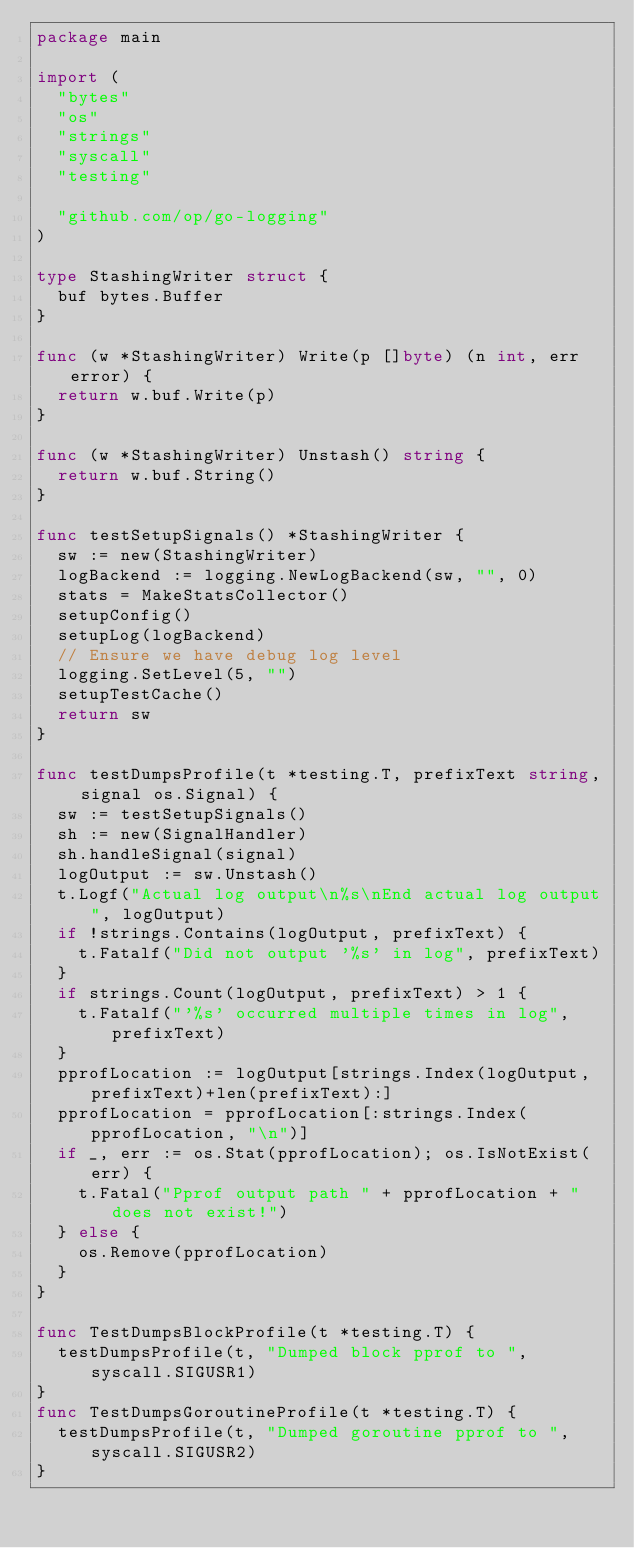Convert code to text. <code><loc_0><loc_0><loc_500><loc_500><_Go_>package main

import (
	"bytes"
	"os"
	"strings"
	"syscall"
	"testing"

	"github.com/op/go-logging"
)

type StashingWriter struct {
	buf bytes.Buffer
}

func (w *StashingWriter) Write(p []byte) (n int, err error) {
	return w.buf.Write(p)
}

func (w *StashingWriter) Unstash() string {
	return w.buf.String()
}

func testSetupSignals() *StashingWriter {
	sw := new(StashingWriter)
	logBackend := logging.NewLogBackend(sw, "", 0)
	stats = MakeStatsCollector()
	setupConfig()
	setupLog(logBackend)
	// Ensure we have debug log level
	logging.SetLevel(5, "")
	setupTestCache()
	return sw
}

func testDumpsProfile(t *testing.T, prefixText string, signal os.Signal) {
	sw := testSetupSignals()
	sh := new(SignalHandler)
	sh.handleSignal(signal)
	logOutput := sw.Unstash()
	t.Logf("Actual log output\n%s\nEnd actual log output", logOutput)
	if !strings.Contains(logOutput, prefixText) {
		t.Fatalf("Did not output '%s' in log", prefixText)
	}
	if strings.Count(logOutput, prefixText) > 1 {
		t.Fatalf("'%s' occurred multiple times in log", prefixText)
	}
	pprofLocation := logOutput[strings.Index(logOutput, prefixText)+len(prefixText):]
	pprofLocation = pprofLocation[:strings.Index(pprofLocation, "\n")]
	if _, err := os.Stat(pprofLocation); os.IsNotExist(err) {
		t.Fatal("Pprof output path " + pprofLocation + " does not exist!")
	} else {
		os.Remove(pprofLocation)
	}
}

func TestDumpsBlockProfile(t *testing.T) {
	testDumpsProfile(t, "Dumped block pprof to ", syscall.SIGUSR1)
}
func TestDumpsGoroutineProfile(t *testing.T) {
	testDumpsProfile(t, "Dumped goroutine pprof to ", syscall.SIGUSR2)
}
</code> 